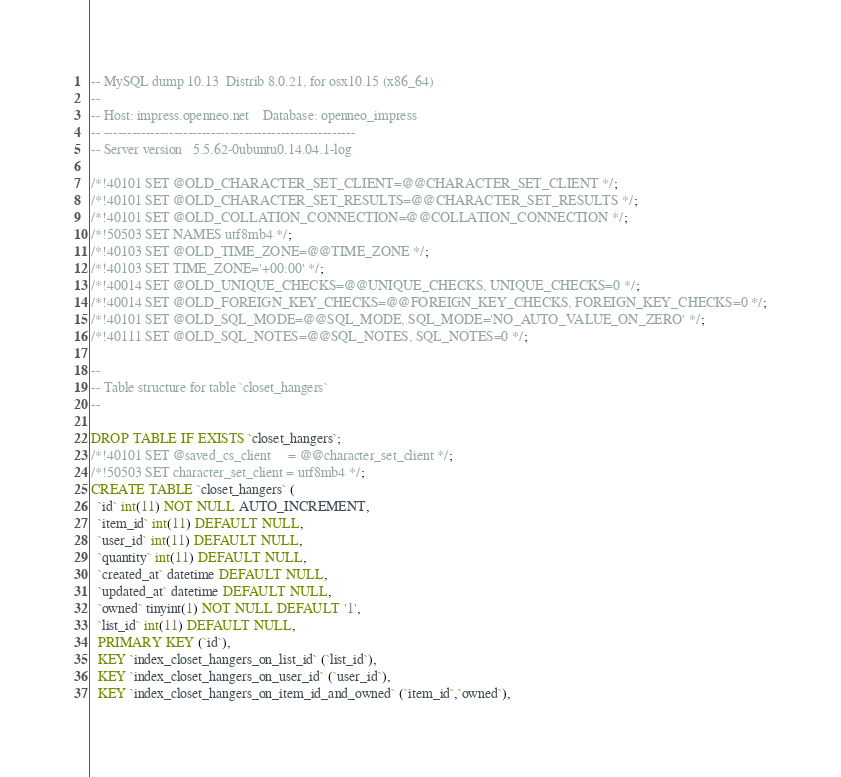Convert code to text. <code><loc_0><loc_0><loc_500><loc_500><_SQL_>-- MySQL dump 10.13  Distrib 8.0.21, for osx10.15 (x86_64)
--
-- Host: impress.openneo.net    Database: openneo_impress
-- ------------------------------------------------------
-- Server version	5.5.62-0ubuntu0.14.04.1-log

/*!40101 SET @OLD_CHARACTER_SET_CLIENT=@@CHARACTER_SET_CLIENT */;
/*!40101 SET @OLD_CHARACTER_SET_RESULTS=@@CHARACTER_SET_RESULTS */;
/*!40101 SET @OLD_COLLATION_CONNECTION=@@COLLATION_CONNECTION */;
/*!50503 SET NAMES utf8mb4 */;
/*!40103 SET @OLD_TIME_ZONE=@@TIME_ZONE */;
/*!40103 SET TIME_ZONE='+00:00' */;
/*!40014 SET @OLD_UNIQUE_CHECKS=@@UNIQUE_CHECKS, UNIQUE_CHECKS=0 */;
/*!40014 SET @OLD_FOREIGN_KEY_CHECKS=@@FOREIGN_KEY_CHECKS, FOREIGN_KEY_CHECKS=0 */;
/*!40101 SET @OLD_SQL_MODE=@@SQL_MODE, SQL_MODE='NO_AUTO_VALUE_ON_ZERO' */;
/*!40111 SET @OLD_SQL_NOTES=@@SQL_NOTES, SQL_NOTES=0 */;

--
-- Table structure for table `closet_hangers`
--

DROP TABLE IF EXISTS `closet_hangers`;
/*!40101 SET @saved_cs_client     = @@character_set_client */;
/*!50503 SET character_set_client = utf8mb4 */;
CREATE TABLE `closet_hangers` (
  `id` int(11) NOT NULL AUTO_INCREMENT,
  `item_id` int(11) DEFAULT NULL,
  `user_id` int(11) DEFAULT NULL,
  `quantity` int(11) DEFAULT NULL,
  `created_at` datetime DEFAULT NULL,
  `updated_at` datetime DEFAULT NULL,
  `owned` tinyint(1) NOT NULL DEFAULT '1',
  `list_id` int(11) DEFAULT NULL,
  PRIMARY KEY (`id`),
  KEY `index_closet_hangers_on_list_id` (`list_id`),
  KEY `index_closet_hangers_on_user_id` (`user_id`),
  KEY `index_closet_hangers_on_item_id_and_owned` (`item_id`,`owned`),</code> 